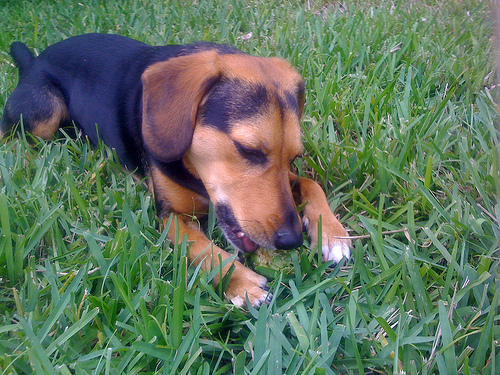<image>
Is the grass on the dog? Yes. Looking at the image, I can see the grass is positioned on top of the dog, with the dog providing support. Is the dog to the left of the grass? No. The dog is not to the left of the grass. From this viewpoint, they have a different horizontal relationship. Where is the dog in relation to the grass? Is it next to the grass? No. The dog is not positioned next to the grass. They are located in different areas of the scene. 